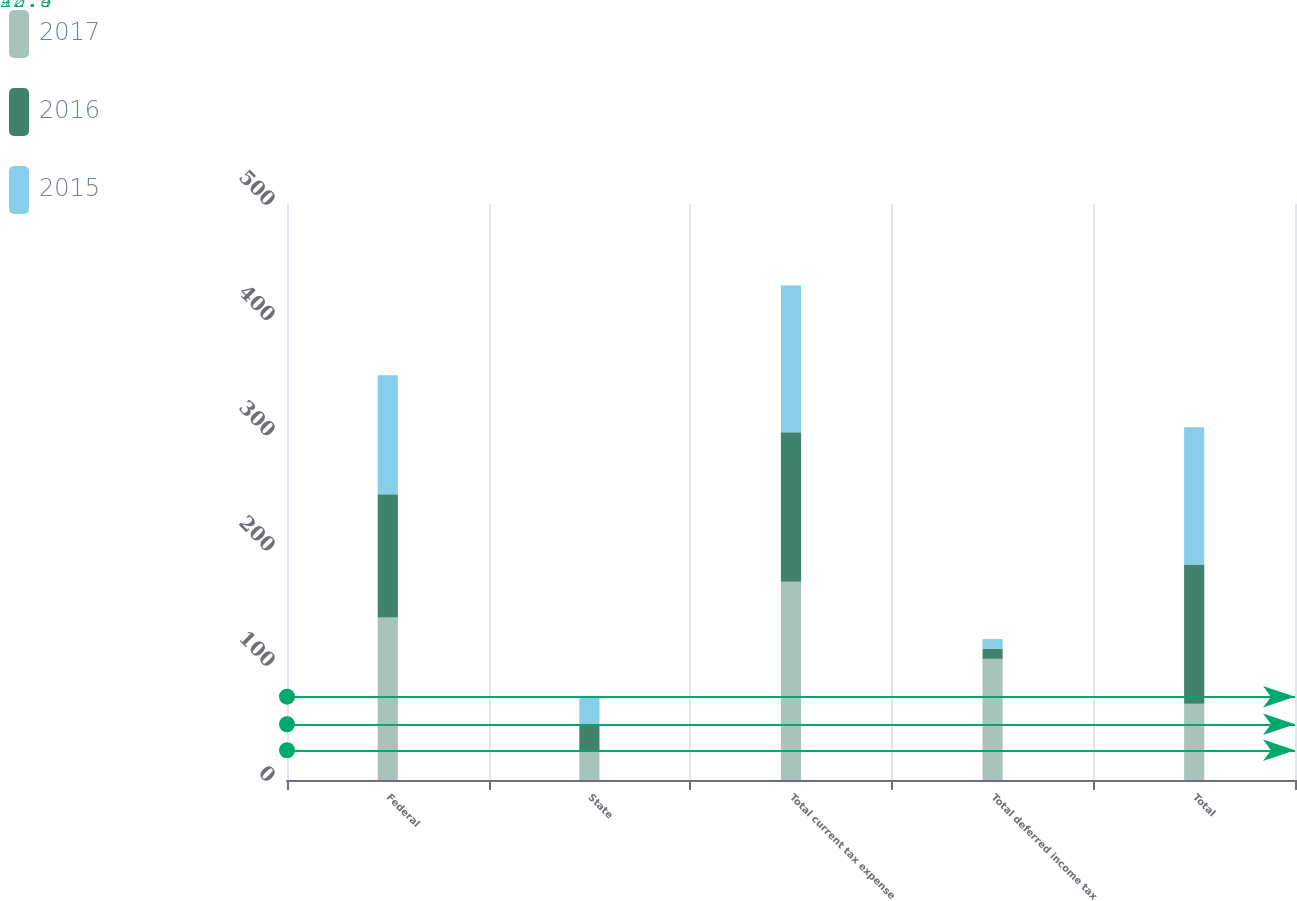Convert chart. <chart><loc_0><loc_0><loc_500><loc_500><stacked_bar_chart><ecel><fcel>Federal<fcel>State<fcel>Total current tax expense<fcel>Total deferred income tax<fcel>Total<nl><fcel>2017<fcel>141<fcel>25.8<fcel>172.2<fcel>105.2<fcel>66.2<nl><fcel>2016<fcel>107.1<fcel>22.6<fcel>129.7<fcel>8.8<fcel>120.9<nl><fcel>2015<fcel>103.3<fcel>23.9<fcel>127.3<fcel>8.3<fcel>119<nl></chart> 